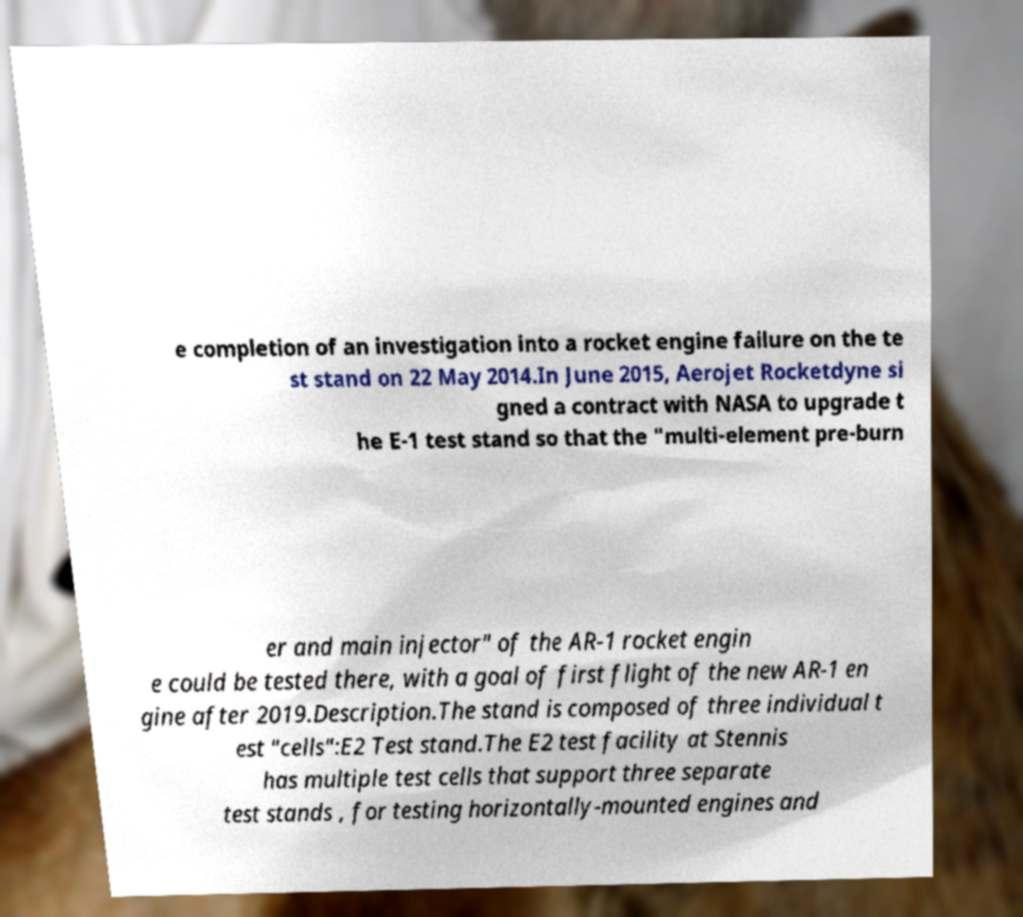Could you extract and type out the text from this image? e completion of an investigation into a rocket engine failure on the te st stand on 22 May 2014.In June 2015, Aerojet Rocketdyne si gned a contract with NASA to upgrade t he E-1 test stand so that the "multi-element pre-burn er and main injector" of the AR-1 rocket engin e could be tested there, with a goal of first flight of the new AR-1 en gine after 2019.Description.The stand is composed of three individual t est "cells":E2 Test stand.The E2 test facility at Stennis has multiple test cells that support three separate test stands , for testing horizontally-mounted engines and 